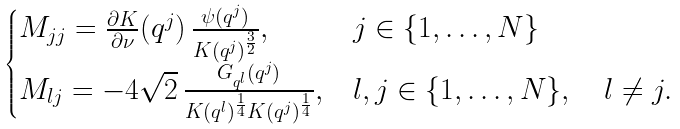Convert formula to latex. <formula><loc_0><loc_0><loc_500><loc_500>\begin{cases} M _ { j j } = \frac { \partial K } { \partial \nu } ( q ^ { j } ) \, \frac { \psi ( q ^ { j } ) } { K ( q ^ { j } ) ^ { \frac { 3 } { 2 } } } , & j \in \{ 1 , \dots , N \} \\ M _ { l j } = - 4 \sqrt { 2 } \, \frac { G _ { q ^ { l } } ( q ^ { j } ) } { K ( q ^ { l } ) ^ { \frac { 1 } { 4 } } K ( q ^ { j } ) ^ { \frac { 1 } { 4 } } } , & l , j \in \{ 1 , \dots , N \} , \quad l \neq j . \end{cases}</formula> 